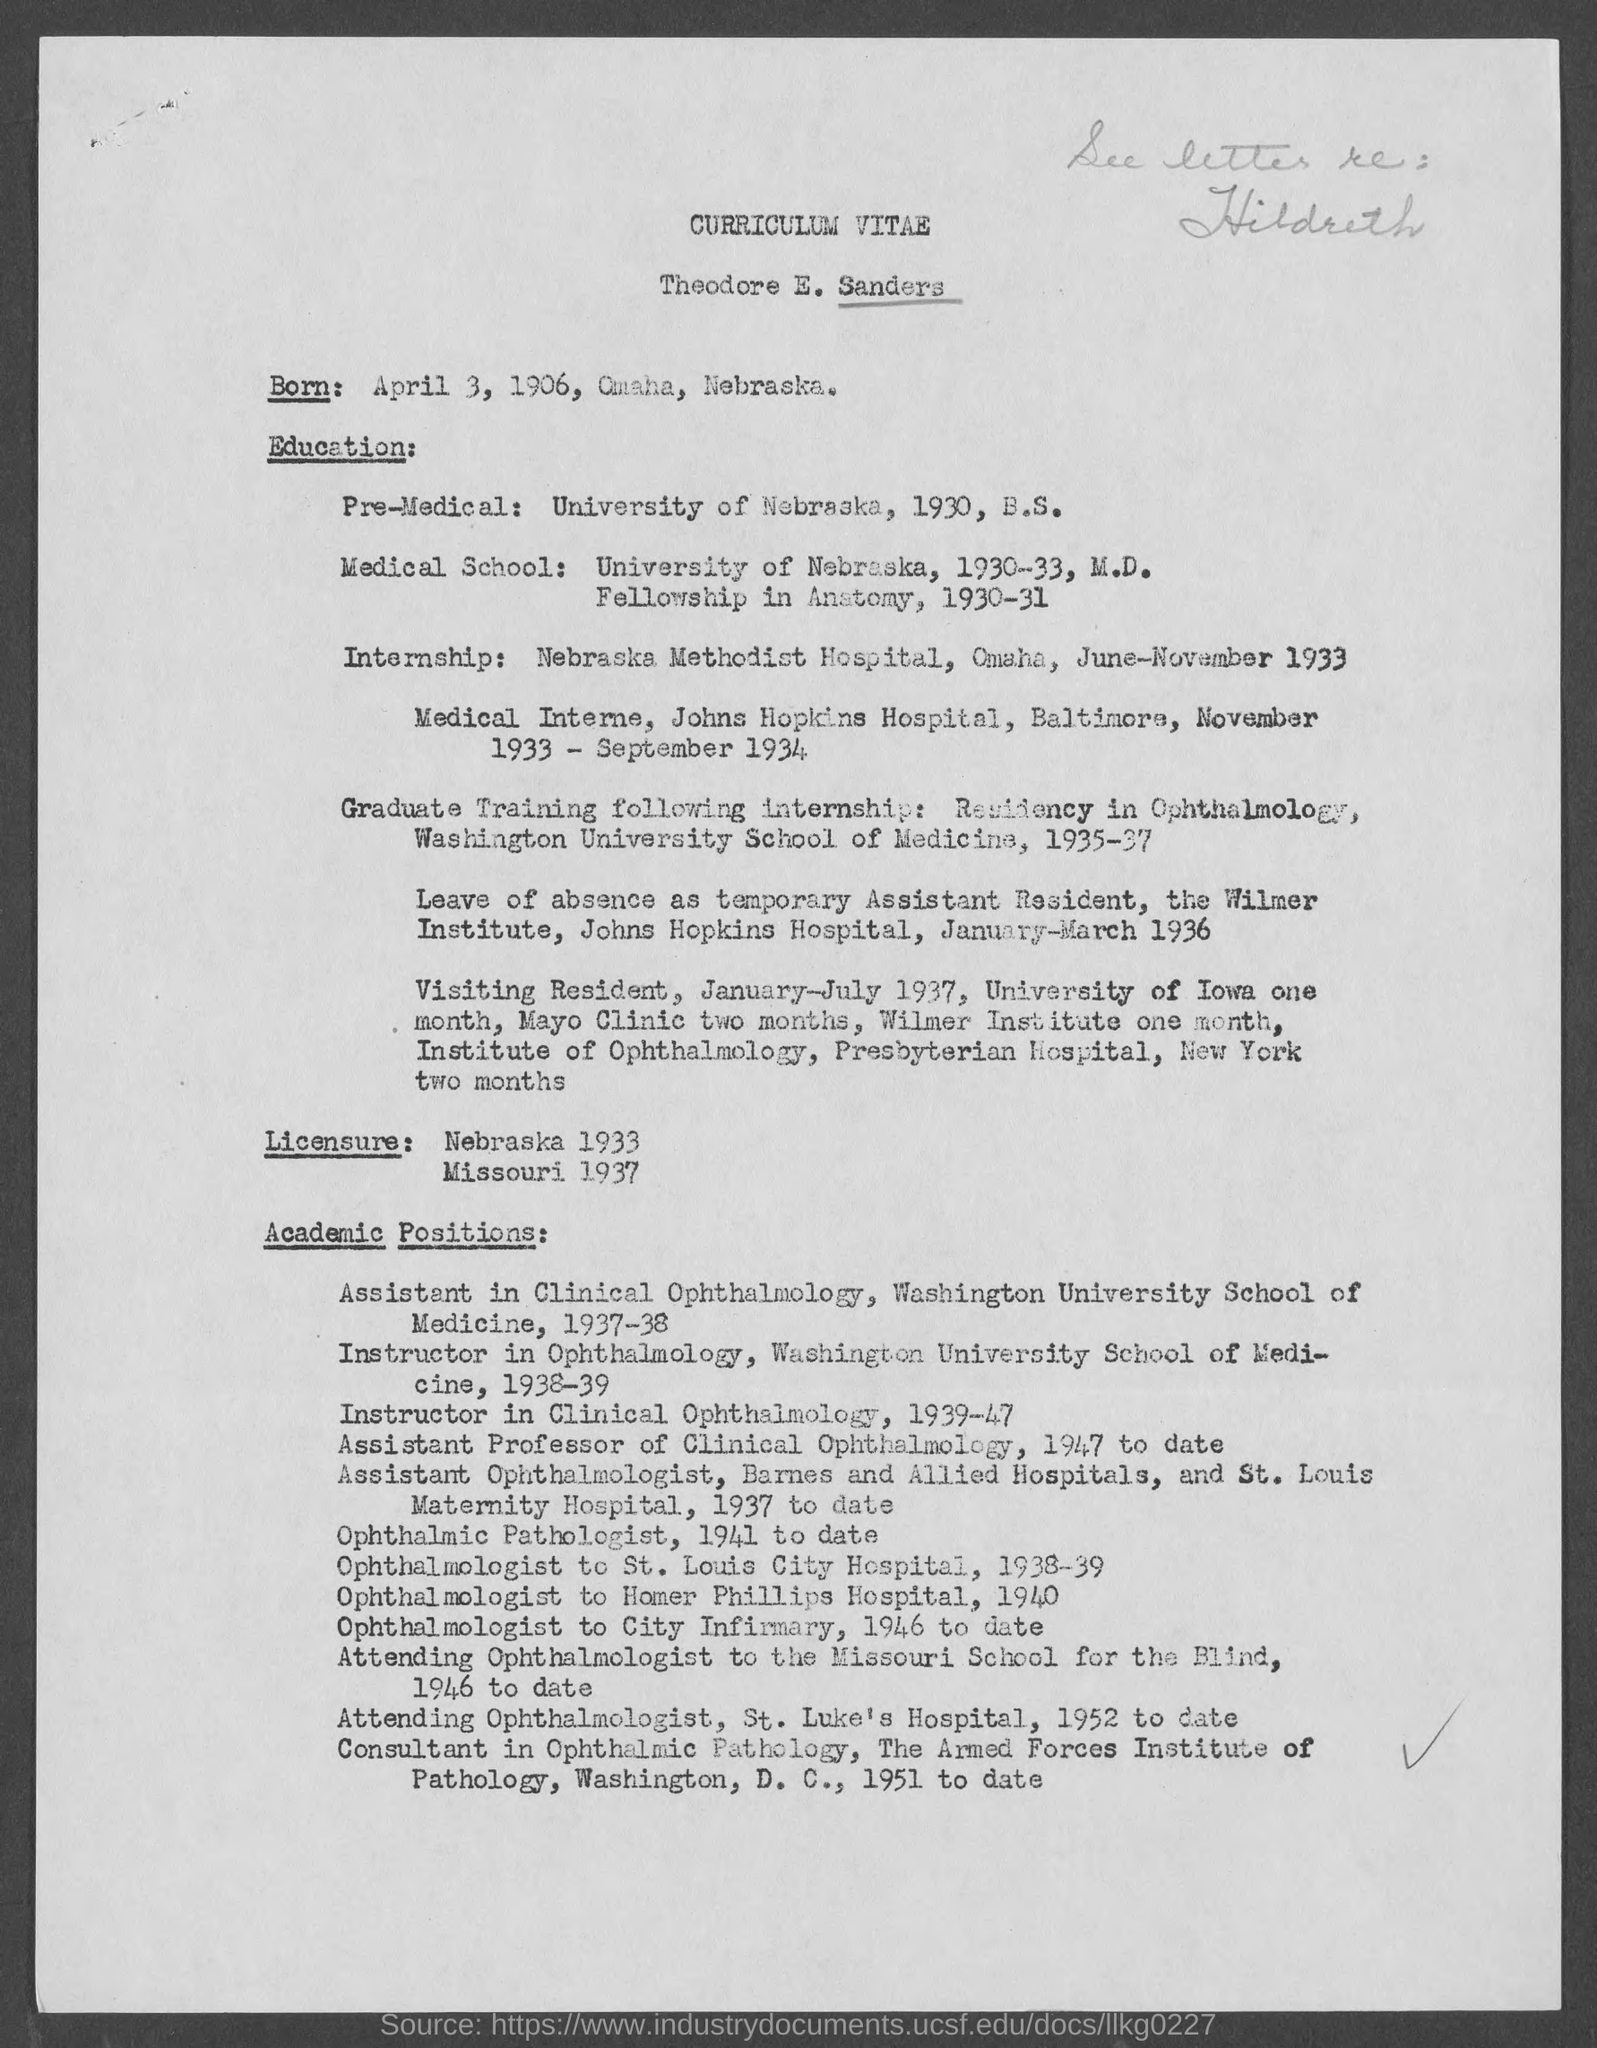What is the name written in curriculum vitae?
Give a very brief answer. Theodore E. Sanders. In which year Theodore E. Sanders worked as instructor in clinical ophthalmology?
Your response must be concise. 1939-47. 